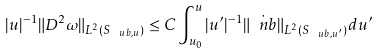<formula> <loc_0><loc_0><loc_500><loc_500>| u | ^ { - 1 } \| D ^ { 2 } \omega \| _ { L ^ { 2 } ( S _ { \ u b , u } ) } \leq C \int _ { u _ { 0 } } ^ { u } | u ^ { \prime } | ^ { - 1 } \| \dot { \ n b } \| _ { L ^ { 2 } ( S _ { \ u b , u ^ { \prime } } ) } d u ^ { \prime }</formula> 